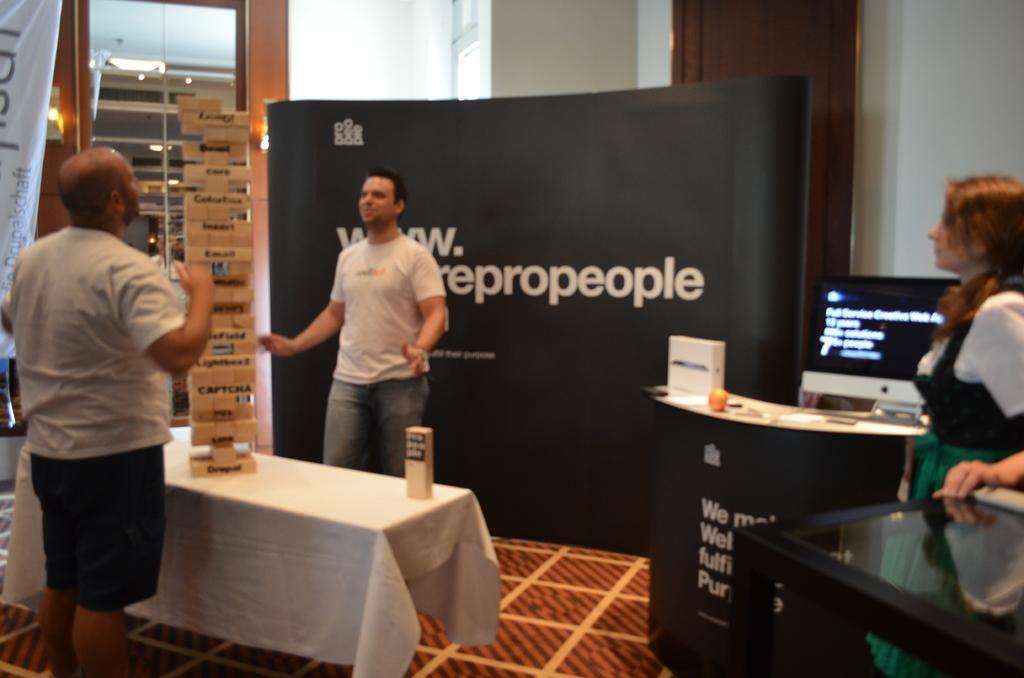Please provide a concise description of this image. In this image there are three persons. To the left side there were two men were playing jenga besides a table. He person to one side of the table, he is wearing white t shirt and blue shorts and another side of a table, a person is wearing white t shirt and blue jeans. To the right side there is a woman she is wearing a green skirt and white shirt, besides her there is a monitor and a table. In the background there is a board and some text on it. To the left corner there is a window 